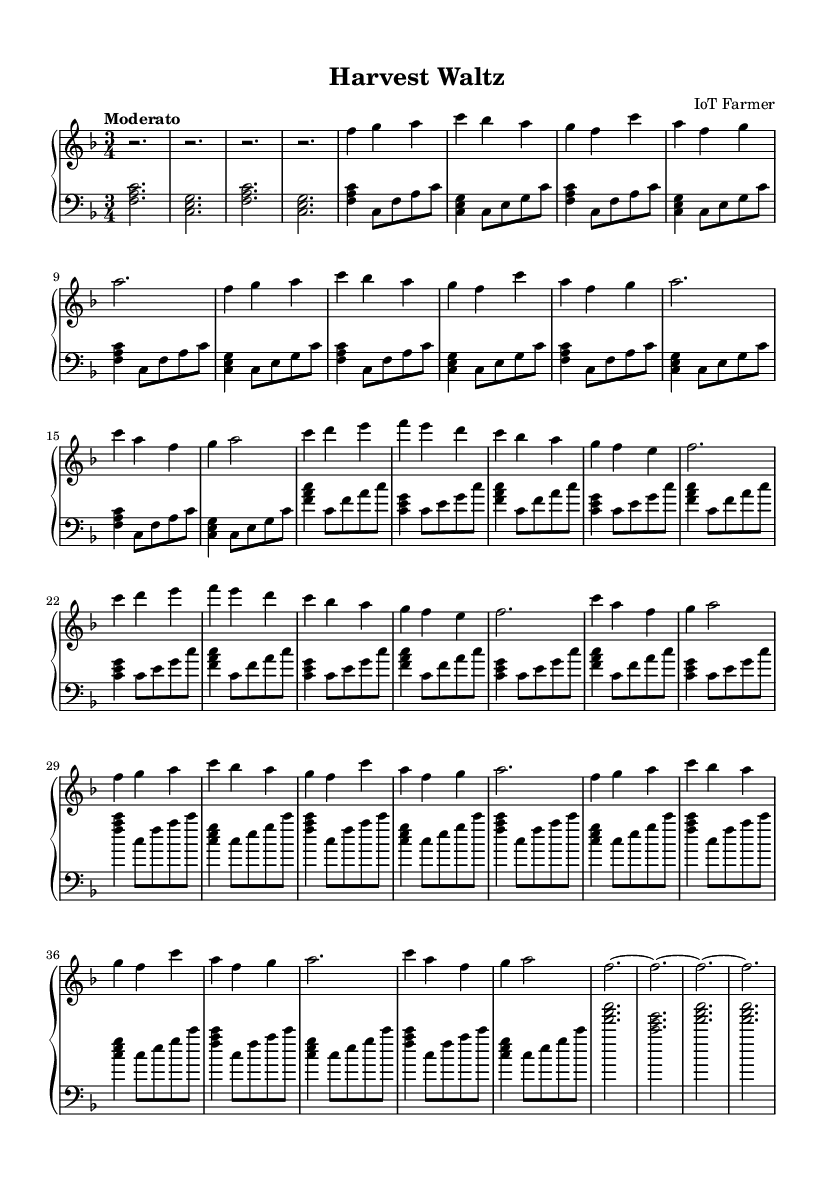What is the key signature of this music? The key signature is F major, which has one flat (B flat).
Answer: F major What is the time signature of this piece? The time signature is 3/4, indicating three beats per measure with a quarter note receiving one beat.
Answer: 3/4 What is the tempo marking for this piece? The tempo marking is "Moderato," which suggests a moderate pace.
Answer: Moderato How many distinct sections are in the music? There are three main sections labeled A, B, and A', along with a coda, making a total of four distinct sections.
Answer: Four In the A section, which notes are used in the main theme? The main theme uses the notes F, G, A, C, B flat, and G.
Answer: F, G, A, C, B flat, G What is the total number of measures in the music? Counting all sections, there are a total of 32 measures throughout the piece.
Answer: 32 What is the structure of the A section? The A section consists of two themes played twice, each with its melodic and rhythmic content.
Answer: Two themes 